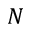<formula> <loc_0><loc_0><loc_500><loc_500>N</formula> 